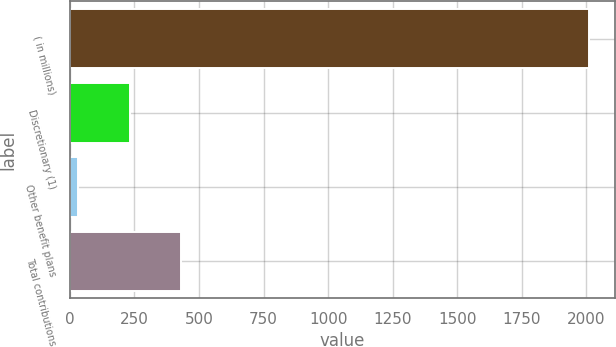Convert chart to OTSL. <chart><loc_0><loc_0><loc_500><loc_500><bar_chart><fcel>( in millions)<fcel>Discretionary (1)<fcel>Other benefit plans<fcel>Total contributions<nl><fcel>2010<fcel>230.7<fcel>33<fcel>428.4<nl></chart> 